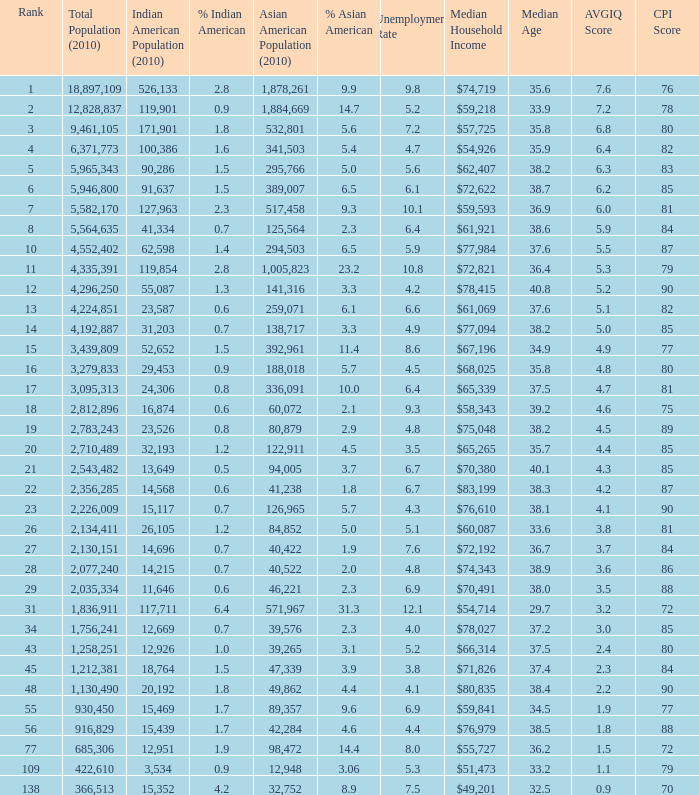What's the total population when the Asian American population is less than 60,072, the Indian American population is more than 14,696 and is 4.2% Indian American? 366513.0. 